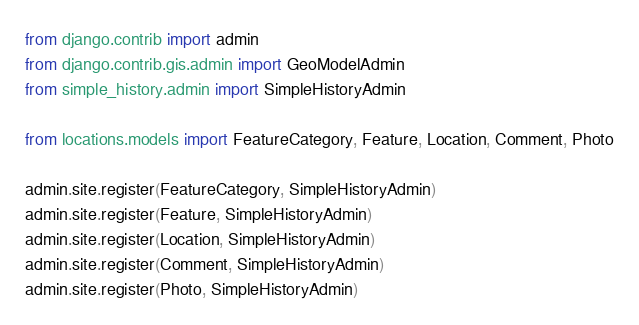Convert code to text. <code><loc_0><loc_0><loc_500><loc_500><_Python_>from django.contrib import admin
from django.contrib.gis.admin import GeoModelAdmin
from simple_history.admin import SimpleHistoryAdmin

from locations.models import FeatureCategory, Feature, Location, Comment, Photo

admin.site.register(FeatureCategory, SimpleHistoryAdmin)
admin.site.register(Feature, SimpleHistoryAdmin)
admin.site.register(Location, SimpleHistoryAdmin)
admin.site.register(Comment, SimpleHistoryAdmin)
admin.site.register(Photo, SimpleHistoryAdmin)
</code> 